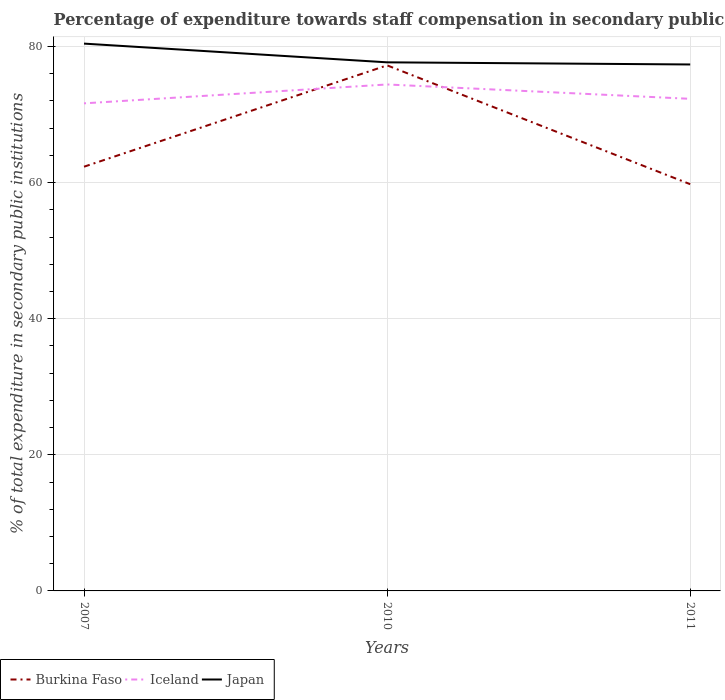How many different coloured lines are there?
Provide a succinct answer. 3. Does the line corresponding to Iceland intersect with the line corresponding to Burkina Faso?
Provide a short and direct response. Yes. Across all years, what is the maximum percentage of expenditure towards staff compensation in Iceland?
Your answer should be very brief. 71.65. In which year was the percentage of expenditure towards staff compensation in Burkina Faso maximum?
Make the answer very short. 2011. What is the total percentage of expenditure towards staff compensation in Burkina Faso in the graph?
Your answer should be very brief. 17.46. What is the difference between the highest and the second highest percentage of expenditure towards staff compensation in Burkina Faso?
Offer a very short reply. 17.46. What is the difference between the highest and the lowest percentage of expenditure towards staff compensation in Burkina Faso?
Your answer should be very brief. 1. What is the difference between two consecutive major ticks on the Y-axis?
Ensure brevity in your answer.  20. Where does the legend appear in the graph?
Your answer should be very brief. Bottom left. What is the title of the graph?
Your answer should be compact. Percentage of expenditure towards staff compensation in secondary public institutions. Does "India" appear as one of the legend labels in the graph?
Give a very brief answer. No. What is the label or title of the Y-axis?
Ensure brevity in your answer.  % of total expenditure in secondary public institutions. What is the % of total expenditure in secondary public institutions in Burkina Faso in 2007?
Provide a succinct answer. 62.34. What is the % of total expenditure in secondary public institutions in Iceland in 2007?
Give a very brief answer. 71.65. What is the % of total expenditure in secondary public institutions in Japan in 2007?
Provide a short and direct response. 80.43. What is the % of total expenditure in secondary public institutions in Burkina Faso in 2010?
Offer a terse response. 77.23. What is the % of total expenditure in secondary public institutions of Iceland in 2010?
Keep it short and to the point. 74.42. What is the % of total expenditure in secondary public institutions of Japan in 2010?
Provide a short and direct response. 77.68. What is the % of total expenditure in secondary public institutions of Burkina Faso in 2011?
Offer a very short reply. 59.77. What is the % of total expenditure in secondary public institutions in Iceland in 2011?
Offer a very short reply. 72.31. What is the % of total expenditure in secondary public institutions of Japan in 2011?
Ensure brevity in your answer.  77.36. Across all years, what is the maximum % of total expenditure in secondary public institutions of Burkina Faso?
Your answer should be compact. 77.23. Across all years, what is the maximum % of total expenditure in secondary public institutions of Iceland?
Give a very brief answer. 74.42. Across all years, what is the maximum % of total expenditure in secondary public institutions of Japan?
Give a very brief answer. 80.43. Across all years, what is the minimum % of total expenditure in secondary public institutions of Burkina Faso?
Offer a very short reply. 59.77. Across all years, what is the minimum % of total expenditure in secondary public institutions in Iceland?
Your response must be concise. 71.65. Across all years, what is the minimum % of total expenditure in secondary public institutions in Japan?
Your response must be concise. 77.36. What is the total % of total expenditure in secondary public institutions of Burkina Faso in the graph?
Your response must be concise. 199.34. What is the total % of total expenditure in secondary public institutions in Iceland in the graph?
Keep it short and to the point. 218.38. What is the total % of total expenditure in secondary public institutions of Japan in the graph?
Your answer should be very brief. 235.46. What is the difference between the % of total expenditure in secondary public institutions of Burkina Faso in 2007 and that in 2010?
Your response must be concise. -14.89. What is the difference between the % of total expenditure in secondary public institutions in Iceland in 2007 and that in 2010?
Your response must be concise. -2.78. What is the difference between the % of total expenditure in secondary public institutions in Japan in 2007 and that in 2010?
Keep it short and to the point. 2.75. What is the difference between the % of total expenditure in secondary public institutions of Burkina Faso in 2007 and that in 2011?
Your answer should be very brief. 2.57. What is the difference between the % of total expenditure in secondary public institutions of Iceland in 2007 and that in 2011?
Keep it short and to the point. -0.67. What is the difference between the % of total expenditure in secondary public institutions in Japan in 2007 and that in 2011?
Offer a very short reply. 3.07. What is the difference between the % of total expenditure in secondary public institutions of Burkina Faso in 2010 and that in 2011?
Your answer should be very brief. 17.46. What is the difference between the % of total expenditure in secondary public institutions in Iceland in 2010 and that in 2011?
Give a very brief answer. 2.11. What is the difference between the % of total expenditure in secondary public institutions of Japan in 2010 and that in 2011?
Make the answer very short. 0.32. What is the difference between the % of total expenditure in secondary public institutions of Burkina Faso in 2007 and the % of total expenditure in secondary public institutions of Iceland in 2010?
Keep it short and to the point. -12.09. What is the difference between the % of total expenditure in secondary public institutions in Burkina Faso in 2007 and the % of total expenditure in secondary public institutions in Japan in 2010?
Offer a very short reply. -15.34. What is the difference between the % of total expenditure in secondary public institutions in Iceland in 2007 and the % of total expenditure in secondary public institutions in Japan in 2010?
Your answer should be very brief. -6.03. What is the difference between the % of total expenditure in secondary public institutions in Burkina Faso in 2007 and the % of total expenditure in secondary public institutions in Iceland in 2011?
Your answer should be compact. -9.97. What is the difference between the % of total expenditure in secondary public institutions of Burkina Faso in 2007 and the % of total expenditure in secondary public institutions of Japan in 2011?
Your answer should be compact. -15.02. What is the difference between the % of total expenditure in secondary public institutions of Iceland in 2007 and the % of total expenditure in secondary public institutions of Japan in 2011?
Your answer should be very brief. -5.71. What is the difference between the % of total expenditure in secondary public institutions in Burkina Faso in 2010 and the % of total expenditure in secondary public institutions in Iceland in 2011?
Ensure brevity in your answer.  4.92. What is the difference between the % of total expenditure in secondary public institutions in Burkina Faso in 2010 and the % of total expenditure in secondary public institutions in Japan in 2011?
Make the answer very short. -0.13. What is the difference between the % of total expenditure in secondary public institutions in Iceland in 2010 and the % of total expenditure in secondary public institutions in Japan in 2011?
Offer a very short reply. -2.94. What is the average % of total expenditure in secondary public institutions in Burkina Faso per year?
Ensure brevity in your answer.  66.45. What is the average % of total expenditure in secondary public institutions of Iceland per year?
Keep it short and to the point. 72.79. What is the average % of total expenditure in secondary public institutions of Japan per year?
Give a very brief answer. 78.49. In the year 2007, what is the difference between the % of total expenditure in secondary public institutions in Burkina Faso and % of total expenditure in secondary public institutions in Iceland?
Make the answer very short. -9.31. In the year 2007, what is the difference between the % of total expenditure in secondary public institutions of Burkina Faso and % of total expenditure in secondary public institutions of Japan?
Your answer should be compact. -18.09. In the year 2007, what is the difference between the % of total expenditure in secondary public institutions of Iceland and % of total expenditure in secondary public institutions of Japan?
Offer a terse response. -8.78. In the year 2010, what is the difference between the % of total expenditure in secondary public institutions of Burkina Faso and % of total expenditure in secondary public institutions of Iceland?
Your answer should be compact. 2.81. In the year 2010, what is the difference between the % of total expenditure in secondary public institutions of Burkina Faso and % of total expenditure in secondary public institutions of Japan?
Give a very brief answer. -0.44. In the year 2010, what is the difference between the % of total expenditure in secondary public institutions of Iceland and % of total expenditure in secondary public institutions of Japan?
Ensure brevity in your answer.  -3.25. In the year 2011, what is the difference between the % of total expenditure in secondary public institutions in Burkina Faso and % of total expenditure in secondary public institutions in Iceland?
Offer a terse response. -12.54. In the year 2011, what is the difference between the % of total expenditure in secondary public institutions in Burkina Faso and % of total expenditure in secondary public institutions in Japan?
Ensure brevity in your answer.  -17.59. In the year 2011, what is the difference between the % of total expenditure in secondary public institutions in Iceland and % of total expenditure in secondary public institutions in Japan?
Provide a short and direct response. -5.05. What is the ratio of the % of total expenditure in secondary public institutions of Burkina Faso in 2007 to that in 2010?
Your answer should be very brief. 0.81. What is the ratio of the % of total expenditure in secondary public institutions of Iceland in 2007 to that in 2010?
Give a very brief answer. 0.96. What is the ratio of the % of total expenditure in secondary public institutions of Japan in 2007 to that in 2010?
Offer a terse response. 1.04. What is the ratio of the % of total expenditure in secondary public institutions of Burkina Faso in 2007 to that in 2011?
Your response must be concise. 1.04. What is the ratio of the % of total expenditure in secondary public institutions in Iceland in 2007 to that in 2011?
Your answer should be compact. 0.99. What is the ratio of the % of total expenditure in secondary public institutions in Japan in 2007 to that in 2011?
Give a very brief answer. 1.04. What is the ratio of the % of total expenditure in secondary public institutions in Burkina Faso in 2010 to that in 2011?
Provide a succinct answer. 1.29. What is the ratio of the % of total expenditure in secondary public institutions of Iceland in 2010 to that in 2011?
Provide a short and direct response. 1.03. What is the ratio of the % of total expenditure in secondary public institutions of Japan in 2010 to that in 2011?
Give a very brief answer. 1. What is the difference between the highest and the second highest % of total expenditure in secondary public institutions in Burkina Faso?
Give a very brief answer. 14.89. What is the difference between the highest and the second highest % of total expenditure in secondary public institutions in Iceland?
Provide a short and direct response. 2.11. What is the difference between the highest and the second highest % of total expenditure in secondary public institutions in Japan?
Provide a succinct answer. 2.75. What is the difference between the highest and the lowest % of total expenditure in secondary public institutions of Burkina Faso?
Offer a terse response. 17.46. What is the difference between the highest and the lowest % of total expenditure in secondary public institutions in Iceland?
Make the answer very short. 2.78. What is the difference between the highest and the lowest % of total expenditure in secondary public institutions in Japan?
Ensure brevity in your answer.  3.07. 